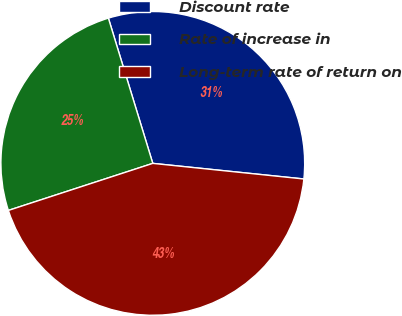Convert chart to OTSL. <chart><loc_0><loc_0><loc_500><loc_500><pie_chart><fcel>Discount rate<fcel>Rate of increase in<fcel>Long-term rate of return on<nl><fcel>31.36%<fcel>25.29%<fcel>43.35%<nl></chart> 